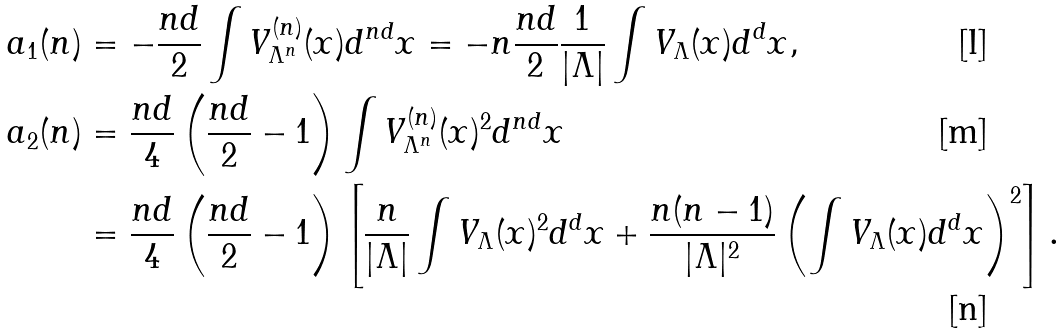Convert formula to latex. <formula><loc_0><loc_0><loc_500><loc_500>a _ { 1 } ( n ) & = - \frac { n d } { 2 } \int V _ { \Lambda ^ { n } } ^ { ( n ) } ( x ) d ^ { n d } x = - n \frac { n d } { 2 } \frac { 1 } { | \Lambda | } \int V _ { \Lambda } ( x ) d ^ { d } x , \\ a _ { 2 } ( n ) & = \frac { n d } { 4 } \left ( \frac { n d } { 2 } - 1 \right ) \int V _ { \Lambda ^ { n } } ^ { ( n ) } ( x ) ^ { 2 } d ^ { n d } x \\ & = \frac { n d } { 4 } \left ( \frac { n d } { 2 } - 1 \right ) \left [ \frac { n } { | \Lambda | } \int V _ { \Lambda } ( x ) ^ { 2 } d ^ { d } x + \frac { n ( n - 1 ) } { | \Lambda | ^ { 2 } } \left ( \int V _ { \Lambda } ( x ) d ^ { d } x \right ) ^ { 2 } \right ] .</formula> 